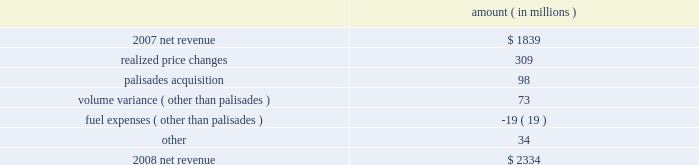Entergy corporation and subsidiaries management's financial discussion and analysis the purchased power capacity variance is primarily due to higher capacity charges .
A portion of the variance is due to the amortization of deferred capacity costs and is offset in base revenues due to base rate increases implemented to recover incremental deferred and ongoing purchased power capacity charges .
The volume/weather variance is primarily due to the effect of less favorable weather compared to the same period in 2007 and decreased electricity usage primarily during the unbilled sales period .
Hurricane gustav and hurricane ike , which hit the utility's service territories in september 2008 , contributed an estimated $ 46 million to the decrease in electricity usage .
Industrial sales were also depressed by the continuing effects of the hurricanes and , especially in the latter part of the year , because of the overall decline of the economy , leading to lower usage in the latter part of the year affecting both the large customer industrial segment as well as small and mid-sized industrial customers .
The decreases in electricity usage were partially offset by an increase in residential and commercial customer electricity usage that occurred during the periods of the year not affected by the hurricanes .
The retail electric price variance is primarily due to : an increase in the attala power plant costs recovered through the power management rider by entergy mississippi .
The net income effect of this recovery is limited to a portion representing an allowed return on equity with the remainder offset by attala power plant costs in other operation and maintenance expenses , depreciation expenses , and taxes other than income taxes ; a storm damage rider that became effective in october 2007 at entergy mississippi ; and an energy efficiency rider that became effective in november 2007 at entergy arkansas .
The establishment of the storm damage rider and the energy efficiency rider results in an increase in rider revenue and a corresponding increase in other operation and maintenance expense with no impact on net income .
The retail electric price variance was partially offset by : the absence of interim storm recoveries through the formula rate plans at entergy louisiana and entergy gulf states louisiana which ceased upon the act 55 financing of storm costs in the third quarter 2008 ; and a credit passed on to customers as a result of the act 55 storm cost financings .
Refer to "liquidity and capital resources - hurricane katrina and hurricane rita" below and note 2 to the financial statements for a discussion of the interim recovery of storm costs and the act 55 storm cost financings .
Non-utility nuclear following is an analysis of the change in net revenue comparing 2008 to 2007 .
Amount ( in millions ) .
As shown in the table above , net revenue for non-utility nuclear increased by $ 495 million , or 27% ( 27 % ) , in 2008 compared to 2007 primarily due to higher pricing in its contracts to sell power , additional production available from the acquisition of palisades in april 2007 , and fewer outage days .
In addition to the refueling outages shown in the .
What portion of the increase in net revenue from non-utility nuclear is attributed to the change in realized price? 
Computations: (309 / 495)
Answer: 0.62424. 